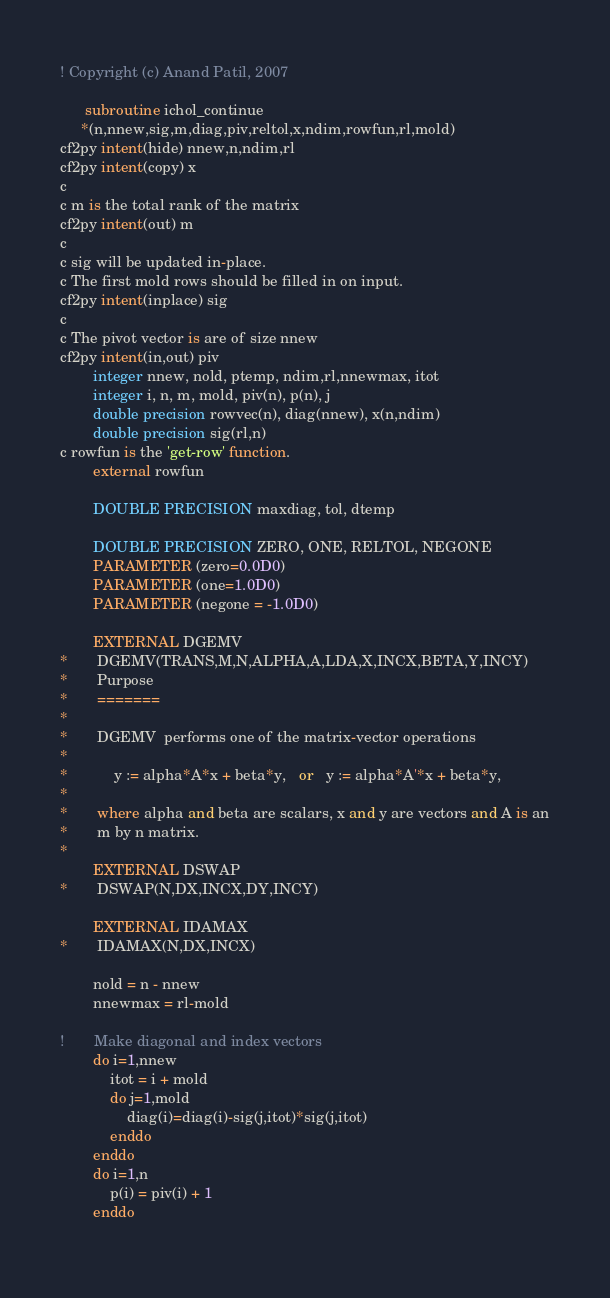<code> <loc_0><loc_0><loc_500><loc_500><_FORTRAN_>! Copyright (c) Anand Patil, 2007

      subroutine ichol_continue      
     *(n,nnew,sig,m,diag,piv,reltol,x,ndim,rowfun,rl,mold)
cf2py intent(hide) nnew,n,ndim,rl
cf2py intent(copy) x
c
c m is the total rank of the matrix
cf2py intent(out) m
c
c sig will be updated in-place. 
c The first mold rows should be filled in on input.
cf2py intent(inplace) sig
c
c The pivot vector is are of size nnew
cf2py intent(in,out) piv
        integer nnew, nold, ptemp, ndim,rl,nnewmax, itot
        integer i, n, m, mold, piv(n), p(n), j
        double precision rowvec(n), diag(nnew), x(n,ndim)
        double precision sig(rl,n)
c rowfun is the 'get-row' function.
        external rowfun

        DOUBLE PRECISION maxdiag, tol, dtemp

        DOUBLE PRECISION ZERO, ONE, RELTOL, NEGONE
        PARAMETER (zero=0.0D0)
        PARAMETER (one=1.0D0)
        PARAMETER (negone = -1.0D0)
        
        EXTERNAL DGEMV
*       DGEMV(TRANS,M,N,ALPHA,A,LDA,X,INCX,BETA,Y,INCY)
*       Purpose
*       =======
*
*       DGEMV  performs one of the matrix-vector operations
*
*           y := alpha*A*x + beta*y,   or   y := alpha*A'*x + beta*y,
*
*       where alpha and beta are scalars, x and y are vectors and A is an
*       m by n matrix.
*
        EXTERNAL DSWAP
*       DSWAP(N,DX,INCX,DY,INCY)

        EXTERNAL IDAMAX
*       IDAMAX(N,DX,INCX)

        nold = n - nnew
        nnewmax = rl-mold

!       Make diagonal and index vectors
        do i=1,nnew
            itot = i + mold
            do j=1,mold
                diag(i)=diag(i)-sig(j,itot)*sig(j,itot)
            enddo
        enddo
        do i=1,n
            p(i) = piv(i) + 1
        enddo
        </code> 